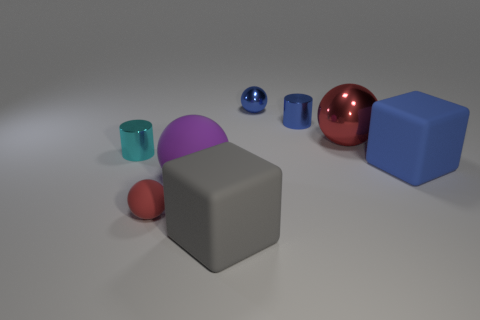Add 1 green matte cylinders. How many objects exist? 9 Subtract all cylinders. How many objects are left? 6 Subtract 1 cyan cylinders. How many objects are left? 7 Subtract all rubber objects. Subtract all small metallic objects. How many objects are left? 1 Add 2 gray cubes. How many gray cubes are left? 3 Add 4 big metallic blocks. How many big metallic blocks exist? 4 